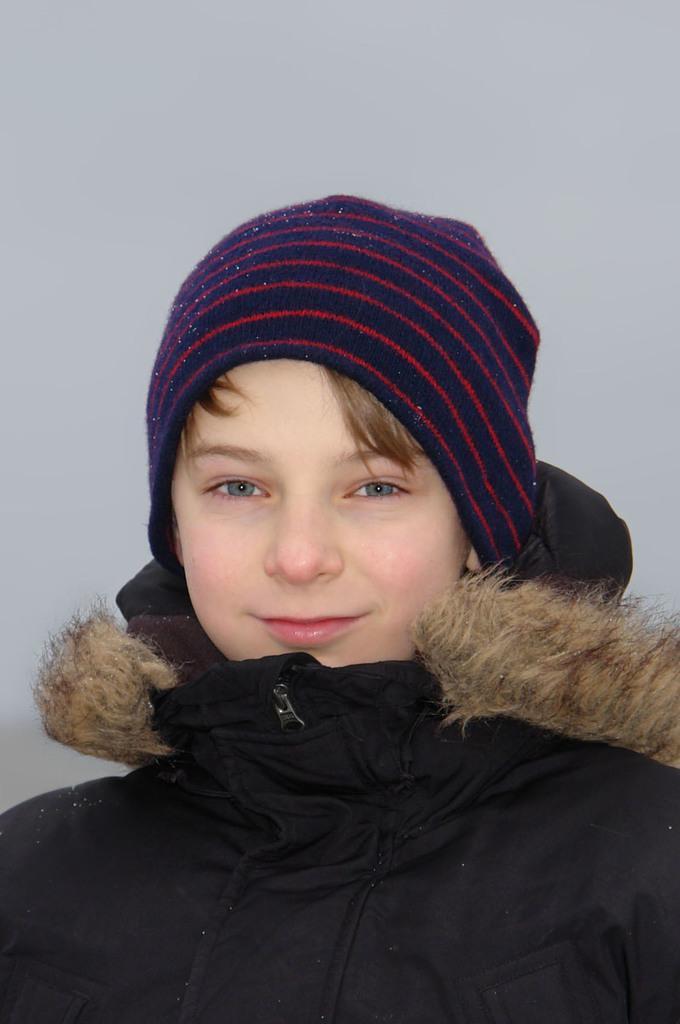Describe this image in one or two sentences. In this image we can see a person and behind the person we can see a white background. 